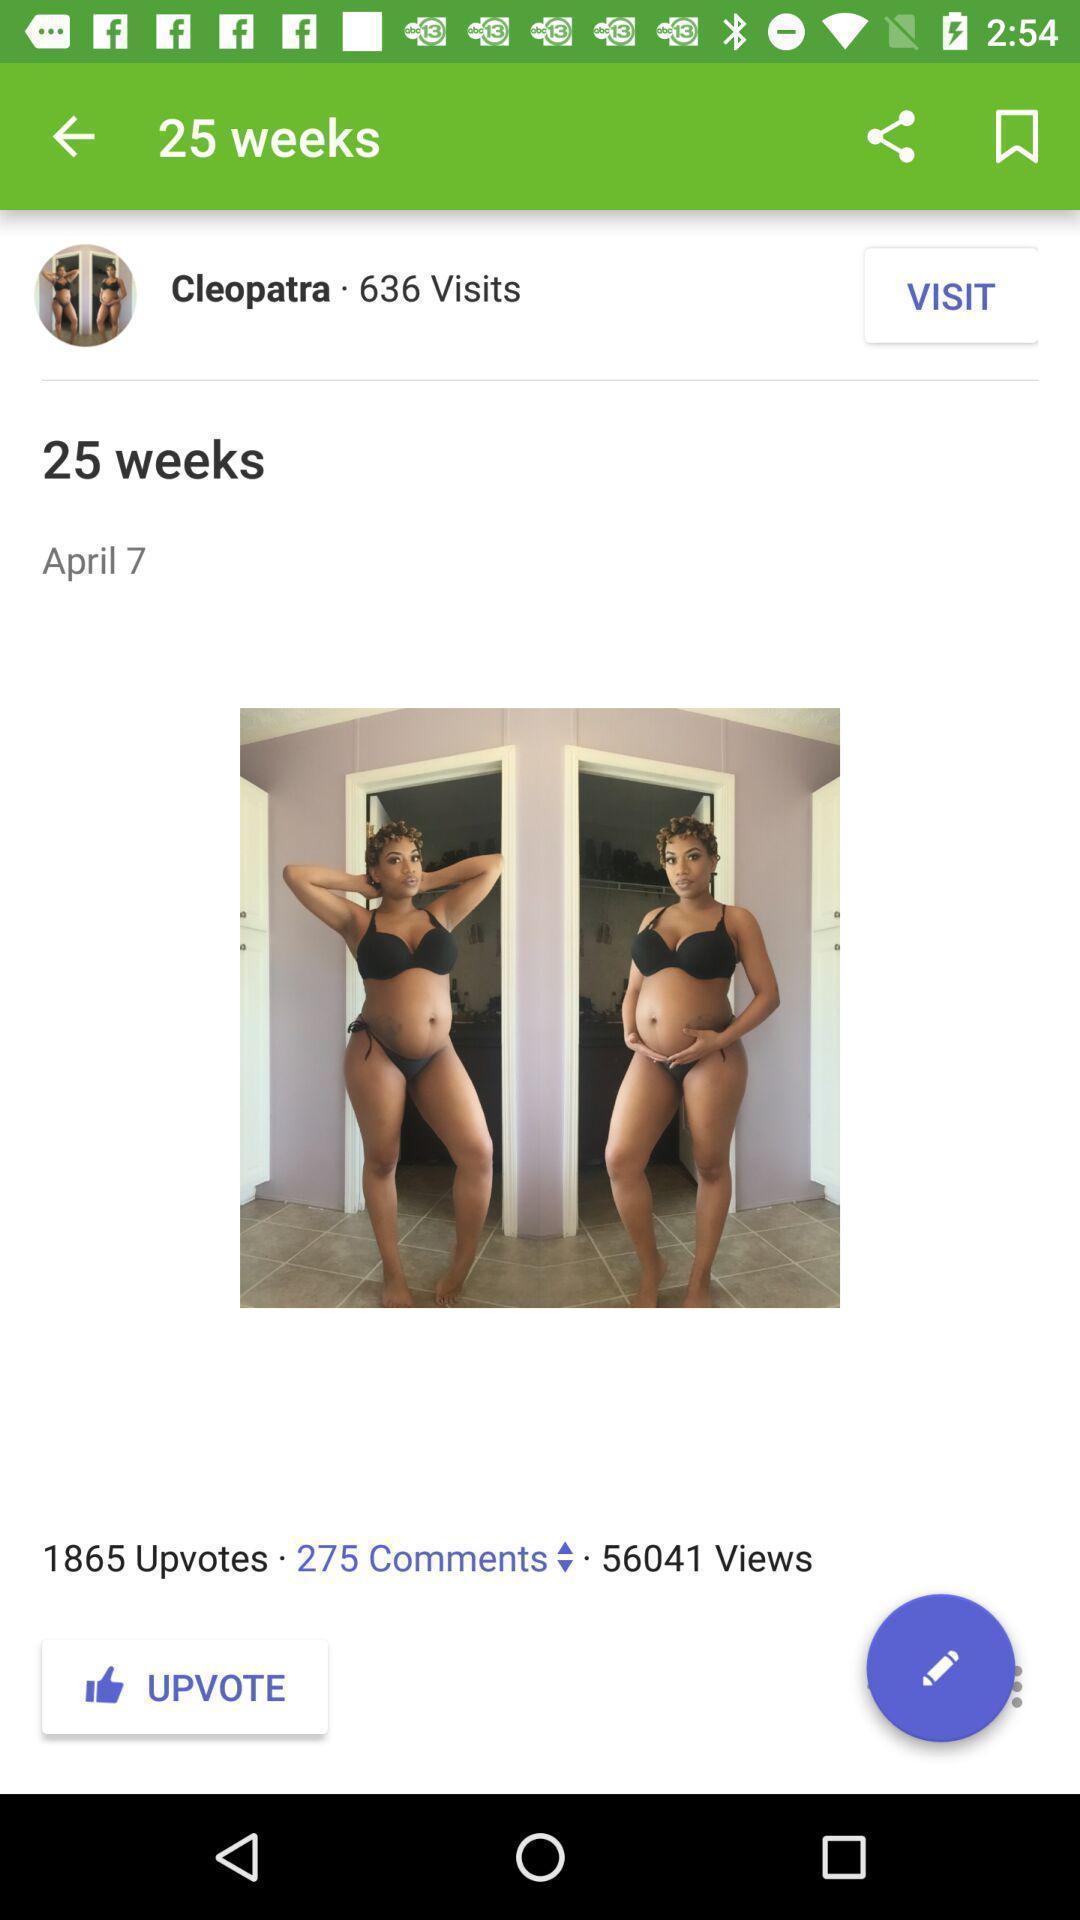Provide a detailed account of this screenshot. Screen shows about live video in broadcasting application. 